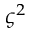<formula> <loc_0><loc_0><loc_500><loc_500>\varsigma ^ { 2 }</formula> 